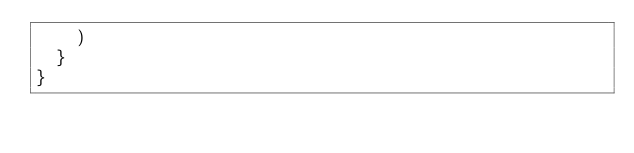<code> <loc_0><loc_0><loc_500><loc_500><_Scala_>    )
  }
}
</code> 